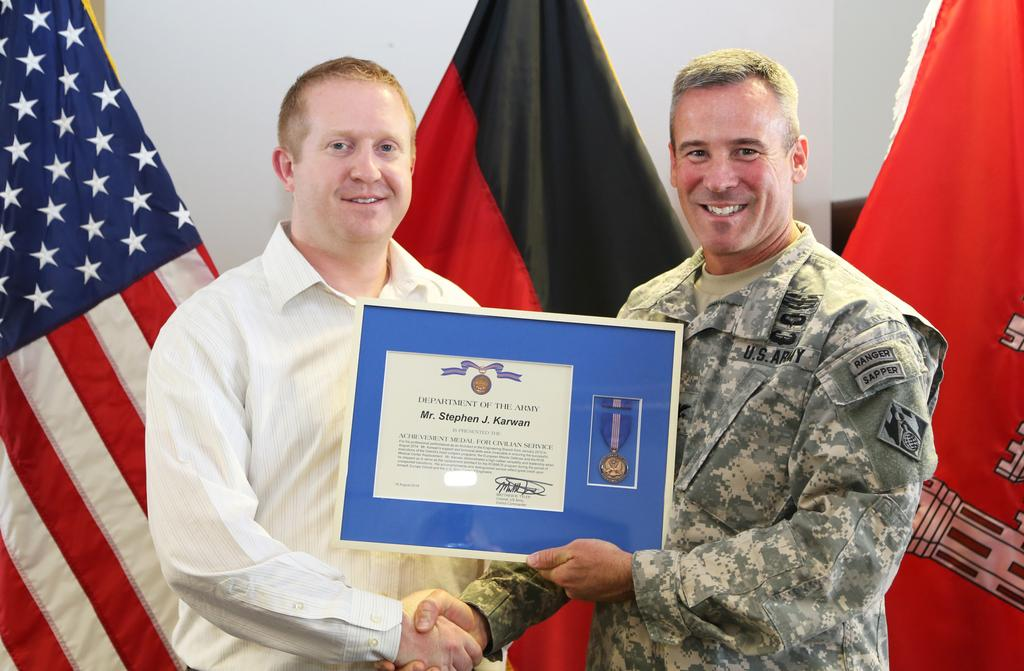How many people are in the image? There are two men in the image. What is the facial expression of the men in the image? Both men are smiling. What is the man on the right holding? The man on the right is holding a frame with his hand. What can be seen in the background of the image? There is a wall and flags in the background of the image. What type of sense does the secretary in the image possess? There is no secretary present in the image. Can you describe the dinosaurs in the image? There are no dinosaurs present in the image. 